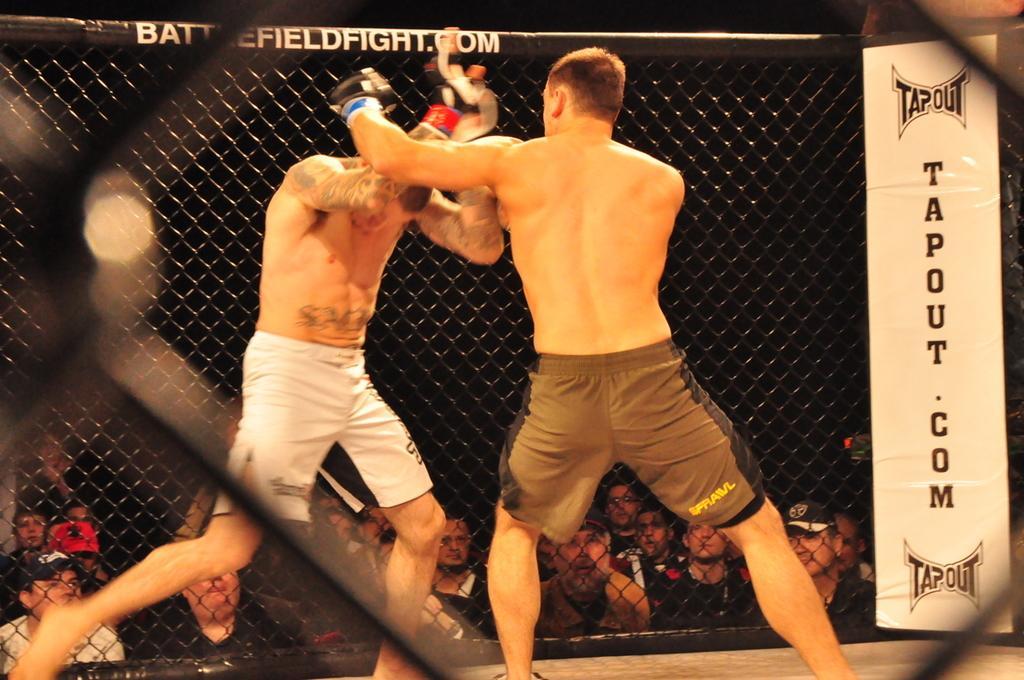Please provide a concise description of this image. There are two men fighting and we can see banner and mesh, through this mess we can see people. In the background it is dark. 